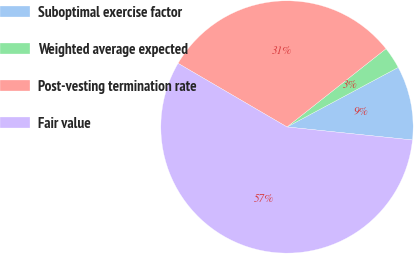Convert chart to OTSL. <chart><loc_0><loc_0><loc_500><loc_500><pie_chart><fcel>Suboptimal exercise factor<fcel>Weighted average expected<fcel>Post-vesting termination rate<fcel>Fair value<nl><fcel>9.47%<fcel>2.82%<fcel>30.94%<fcel>56.76%<nl></chart> 